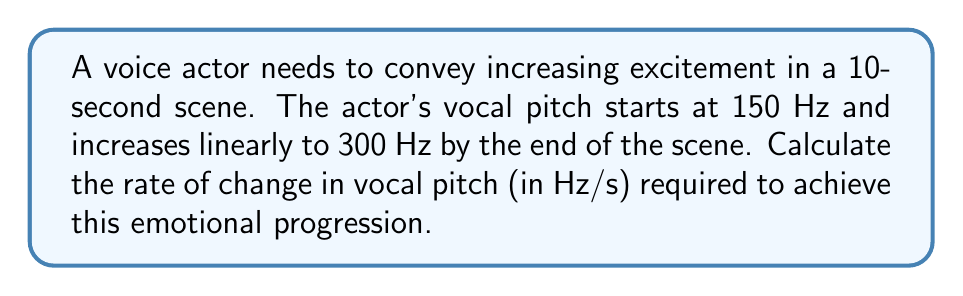Give your solution to this math problem. To solve this problem, we need to use the concept of rate of change, which is essentially the slope of a linear function. We can calculate this using the formula:

$$\text{Rate of change} = \frac{\text{Change in y}}{\text{Change in x}} = \frac{\Delta y}{\Delta x}$$

Given:
- Initial pitch: 150 Hz
- Final pitch: 300 Hz
- Time duration: 10 seconds

Step 1: Calculate the change in pitch (Δy)
$$\Delta y = \text{Final pitch} - \text{Initial pitch} = 300 \text{ Hz} - 150 \text{ Hz} = 150 \text{ Hz}$$

Step 2: Identify the change in time (Δx)
$$\Delta x = 10 \text{ seconds}$$

Step 3: Apply the rate of change formula
$$\text{Rate of change} = \frac{\Delta y}{\Delta x} = \frac{150 \text{ Hz}}{10 \text{ s}} = 15 \text{ Hz/s}$$

Therefore, the rate of change in vocal pitch required to convey increasing excitement is 15 Hz per second.
Answer: 15 Hz/s 